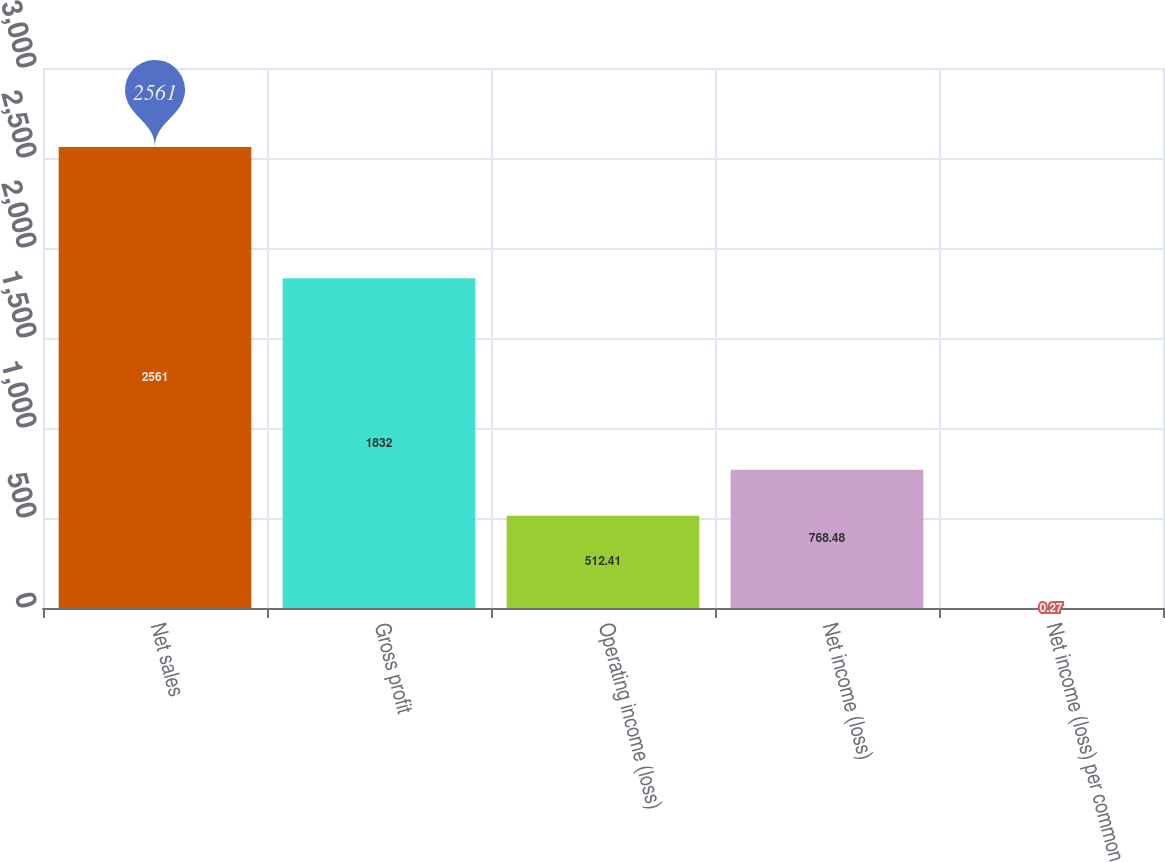Convert chart to OTSL. <chart><loc_0><loc_0><loc_500><loc_500><bar_chart><fcel>Net sales<fcel>Gross profit<fcel>Operating income (loss)<fcel>Net income (loss)<fcel>Net income (loss) per common<nl><fcel>2561<fcel>1832<fcel>512.41<fcel>768.48<fcel>0.27<nl></chart> 